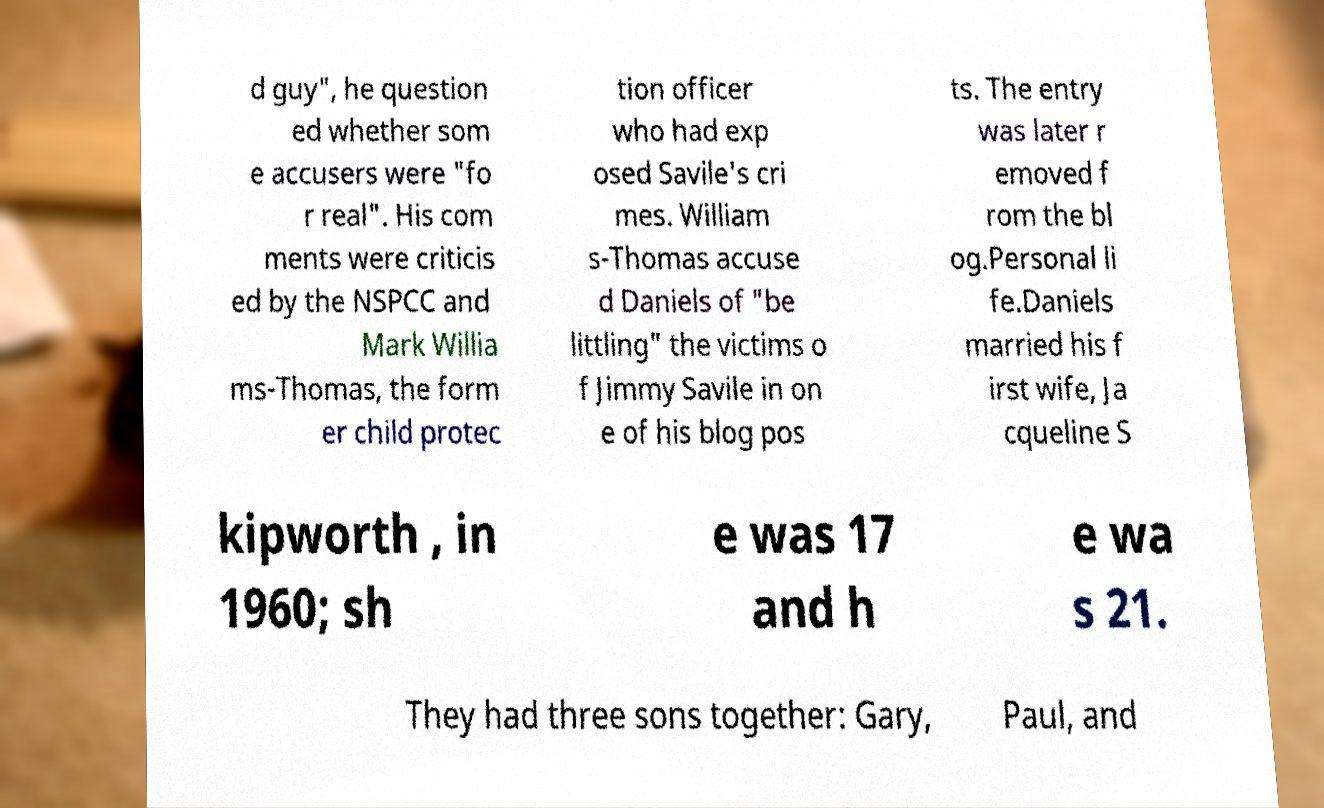Please read and relay the text visible in this image. What does it say? d guy", he question ed whether som e accusers were "fo r real". His com ments were criticis ed by the NSPCC and Mark Willia ms-Thomas, the form er child protec tion officer who had exp osed Savile's cri mes. William s-Thomas accuse d Daniels of "be littling" the victims o f Jimmy Savile in on e of his blog pos ts. The entry was later r emoved f rom the bl og.Personal li fe.Daniels married his f irst wife, Ja cqueline S kipworth , in 1960; sh e was 17 and h e wa s 21. They had three sons together: Gary, Paul, and 